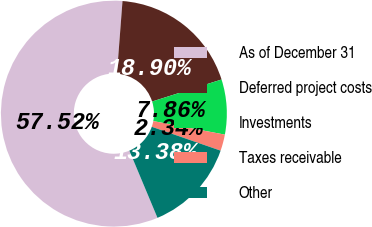Convert chart to OTSL. <chart><loc_0><loc_0><loc_500><loc_500><pie_chart><fcel>As of December 31<fcel>Deferred project costs<fcel>Investments<fcel>Taxes receivable<fcel>Other<nl><fcel>57.53%<fcel>18.9%<fcel>7.86%<fcel>2.34%<fcel>13.38%<nl></chart> 